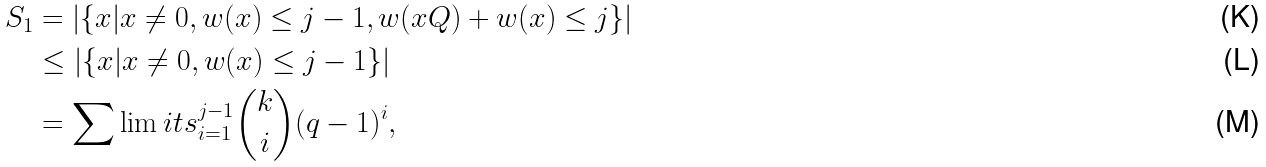<formula> <loc_0><loc_0><loc_500><loc_500>S _ { 1 } & = | \{ { x } | { x } \neq { 0 } , w ( { x } ) \leq j - 1 , w ( { x } Q ) + w ( { x } ) \leq j \} | \\ & \leq | \{ { x } | { x } \neq { 0 } , w ( { x } ) \leq j - 1 \} | \\ & = \sum \lim i t s _ { i = 1 } ^ { j - 1 } \binom { k } { i } ( q - 1 ) ^ { i } ,</formula> 